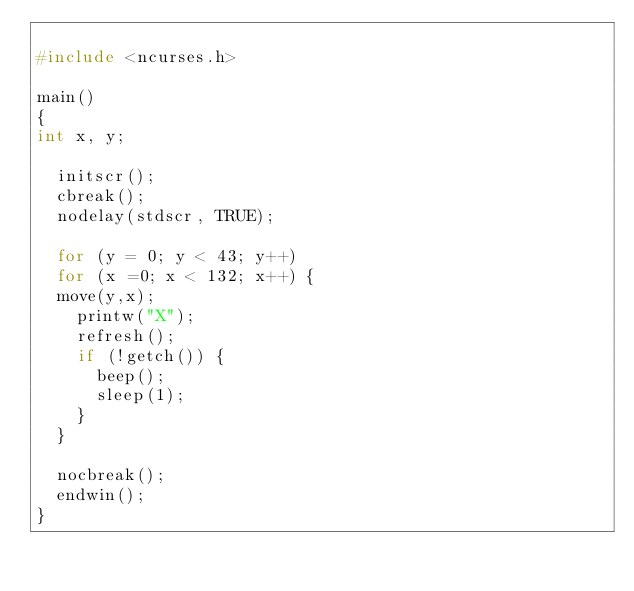Convert code to text. <code><loc_0><loc_0><loc_500><loc_500><_C_>
#include <ncurses.h>

main()
{
int x, y;

  initscr();
  cbreak();
  nodelay(stdscr, TRUE);

  for (y = 0; y < 43; y++)
  for (x =0; x < 132; x++) {
  move(y,x);
    printw("X");
    refresh();
    if (!getch()) {
    	beep();
    	sleep(1);
    }
  }

  nocbreak();
  endwin();
}


</code> 